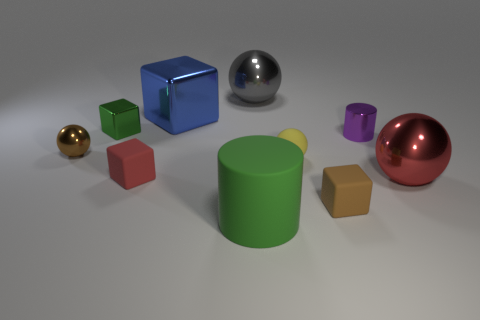Subtract all spheres. How many objects are left? 6 Subtract all tiny purple cylinders. Subtract all large gray metal objects. How many objects are left? 8 Add 2 rubber cylinders. How many rubber cylinders are left? 3 Add 2 small brown matte blocks. How many small brown matte blocks exist? 3 Subtract 0 brown cylinders. How many objects are left? 10 